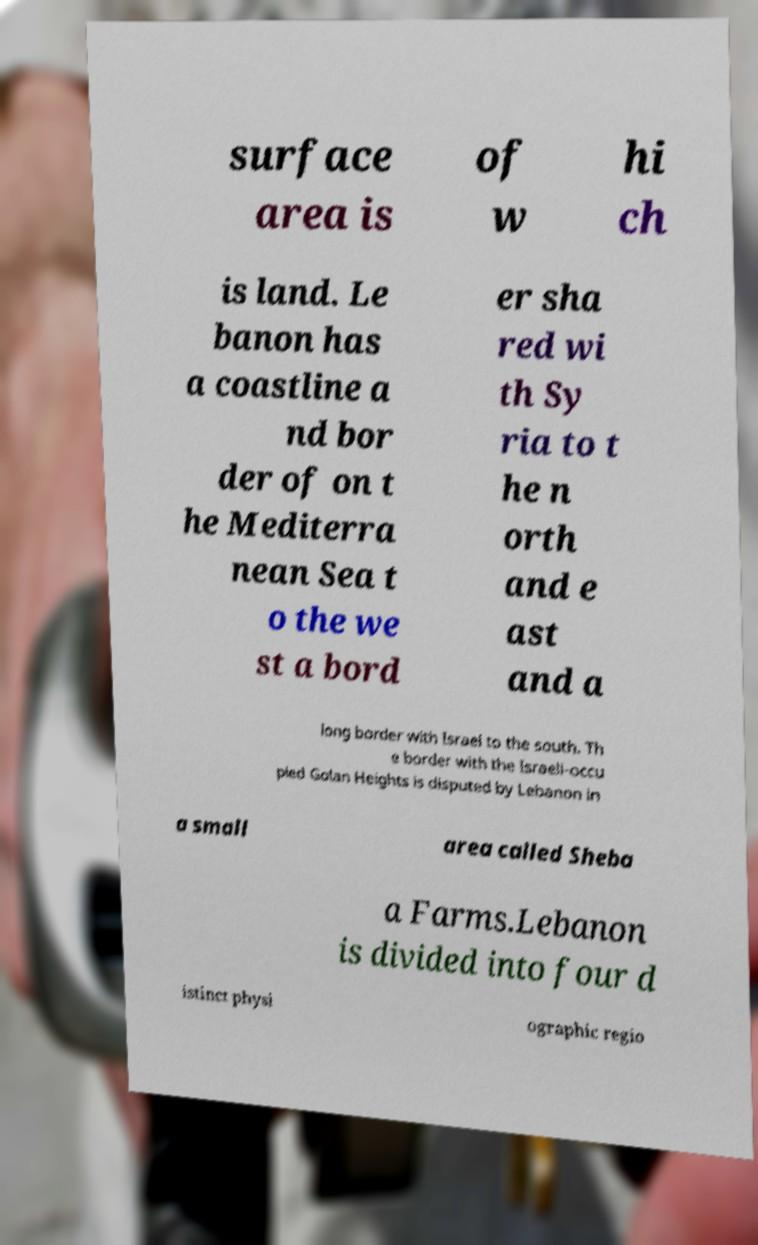Could you extract and type out the text from this image? surface area is of w hi ch is land. Le banon has a coastline a nd bor der of on t he Mediterra nean Sea t o the we st a bord er sha red wi th Sy ria to t he n orth and e ast and a long border with Israel to the south. Th e border with the Israeli-occu pied Golan Heights is disputed by Lebanon in a small area called Sheba a Farms.Lebanon is divided into four d istinct physi ographic regio 